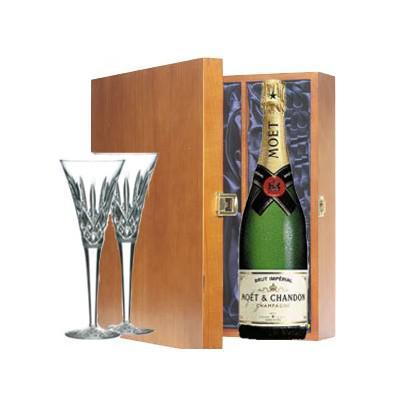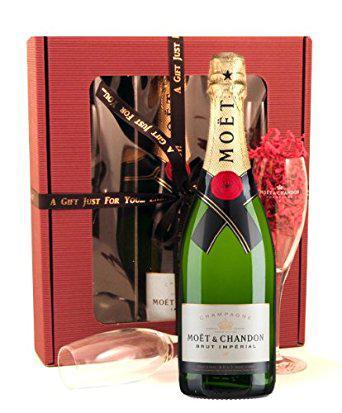The first image is the image on the left, the second image is the image on the right. For the images displayed, is the sentence "Two wine glasses filled with liquid can be seen." factually correct? Answer yes or no. No. The first image is the image on the left, the second image is the image on the right. Assess this claim about the two images: "Two glasses have champagne in them.". Correct or not? Answer yes or no. No. 